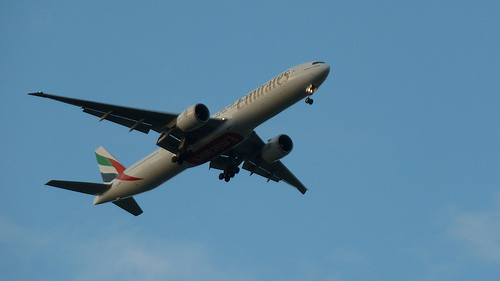What is this plane in? This plane is in the air, flying solo under clear blue sky conditions. 